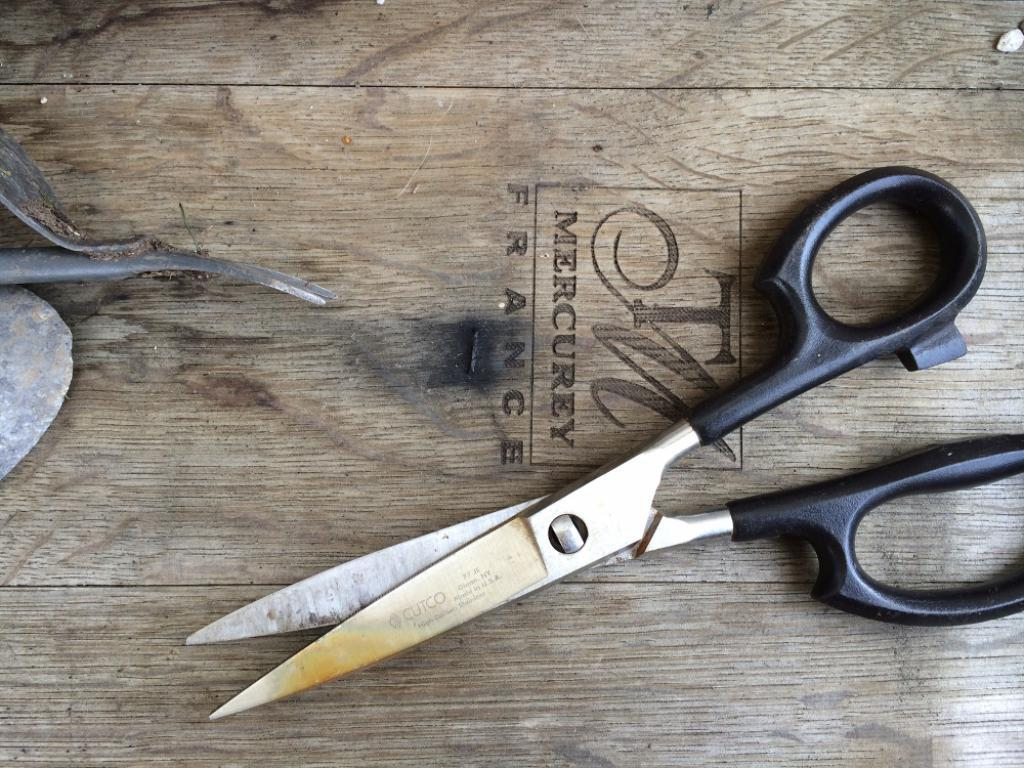What is the main object on the table in the image? There is a scissors on the table. Can you describe the other object on the table? Unfortunately, the provided facts do not give any information about the other object on the table. How many spiders are crawling on the scissors in the image? There are no spiders present in the image; it only shows a scissors and another object on the table. 